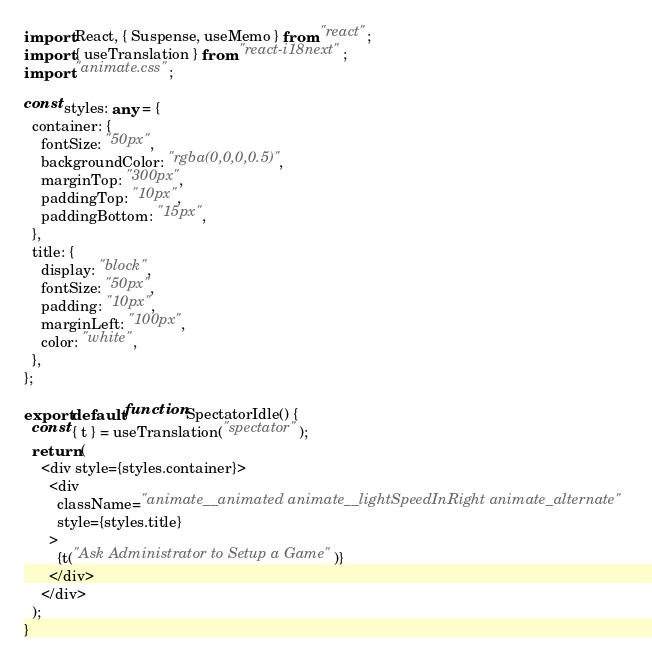<code> <loc_0><loc_0><loc_500><loc_500><_TypeScript_>import React, { Suspense, useMemo } from "react";
import { useTranslation } from "react-i18next";
import "animate.css";

const styles: any = {
  container: {
    fontSize: "50px",
    backgroundColor: "rgba(0,0,0,0.5)",
    marginTop: "300px",
    paddingTop: "10px",
    paddingBottom: "15px",
  },
  title: {
    display: "block",
    fontSize: "50px",
    padding: "10px",
    marginLeft: "100px",
    color: "white",
  },
};

export default function SpectatorIdle() {
  const { t } = useTranslation("spectator");
  return (
    <div style={styles.container}>
      <div
        className="animate__animated animate__lightSpeedInRight animate_alternate"
        style={styles.title}
      >
        {t("Ask Administrator to Setup a Game")}
      </div>
    </div>
  );
}
</code> 